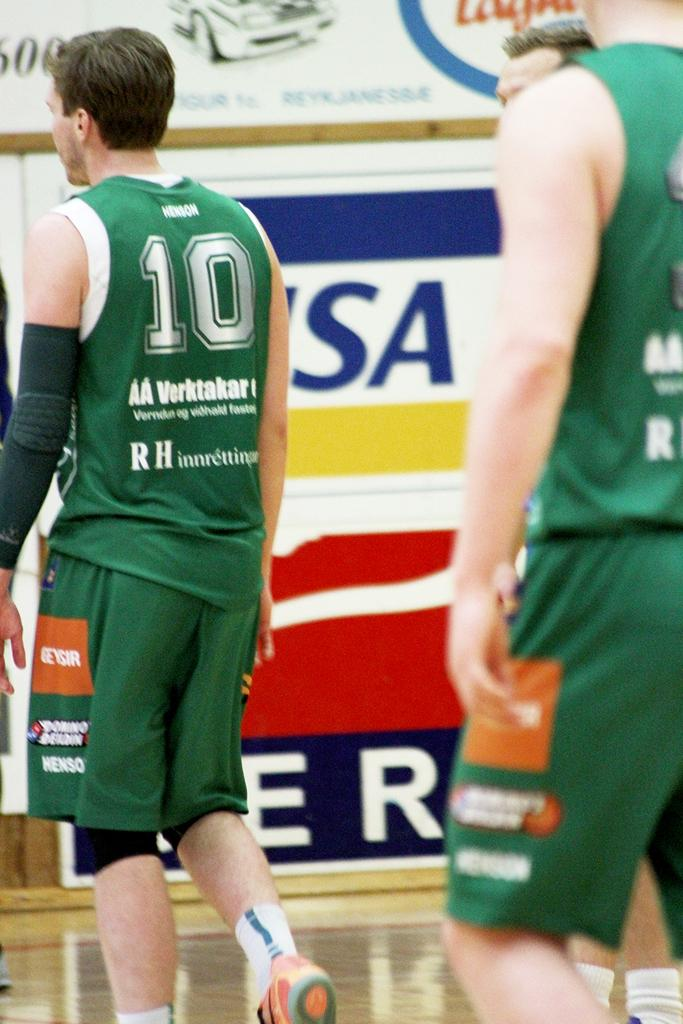<image>
Summarize the visual content of the image. A basketball player with AA Verktakar written on the back of his jersey. 